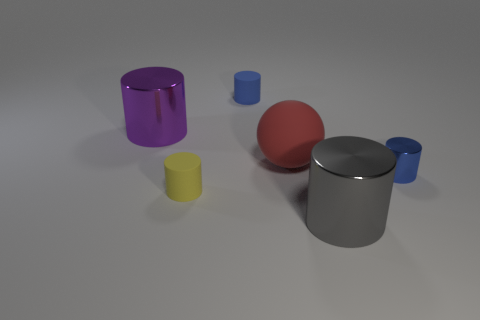Subtract all purple cylinders. How many cylinders are left? 4 Subtract all brown cubes. How many blue cylinders are left? 2 Subtract all gray cylinders. How many cylinders are left? 4 Subtract 3 cylinders. How many cylinders are left? 2 Subtract all cylinders. How many objects are left? 1 Add 2 red things. How many objects exist? 8 Subtract all purple cylinders. Subtract all cyan spheres. How many cylinders are left? 4 Subtract all large gray metallic spheres. Subtract all blue shiny cylinders. How many objects are left? 5 Add 4 big purple objects. How many big purple objects are left? 5 Add 1 big gray metal objects. How many big gray metal objects exist? 2 